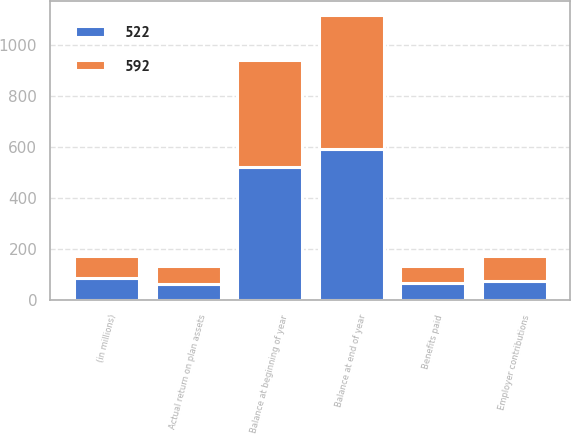<chart> <loc_0><loc_0><loc_500><loc_500><stacked_bar_chart><ecel><fcel>(in millions)<fcel>Balance at beginning of year<fcel>Actual return on plan assets<fcel>Employer contributions<fcel>Benefits paid<fcel>Balance at end of year<nl><fcel>522<fcel>87.5<fcel>522<fcel>64<fcel>74<fcel>68<fcel>592<nl><fcel>592<fcel>87.5<fcel>417<fcel>70<fcel>101<fcel>66<fcel>522<nl></chart> 